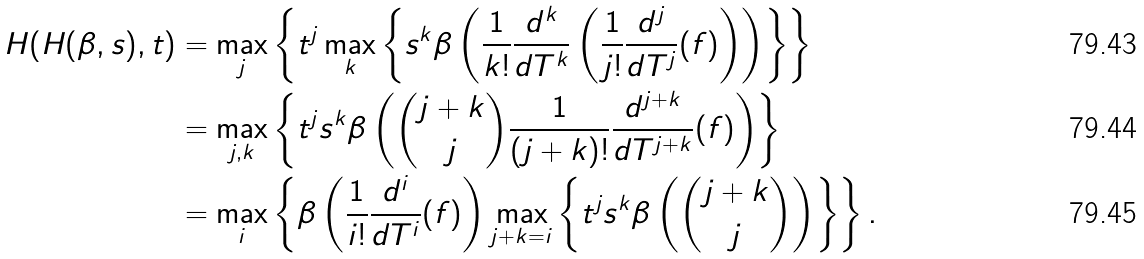<formula> <loc_0><loc_0><loc_500><loc_500>H ( H ( \beta , s ) , t ) & = \max _ { j } \left \{ t ^ { j } \max _ { k } \left \{ s ^ { k } \beta \left ( \frac { 1 } { k ! } \frac { d ^ { k } } { d T ^ { k } } \left ( \frac { 1 } { j ! } \frac { d ^ { j } } { d T ^ { j } } ( f ) \right ) \right ) \right \} \right \} \\ & = \max _ { j , k } \left \{ t ^ { j } s ^ { k } \beta \left ( \binom { j + k } { j } \frac { 1 } { ( j + k ) ! } \frac { d ^ { j + k } } { d T ^ { j + k } } ( f ) \right ) \right \} \\ & = \max _ { i } \left \{ \beta \left ( \frac { 1 } { i ! } \frac { d ^ { i } } { d T ^ { i } } ( f ) \right ) \max _ { j + k = i } \left \{ t ^ { j } s ^ { k } \beta \left ( \binom { j + k } { j } \right ) \right \} \right \} .</formula> 